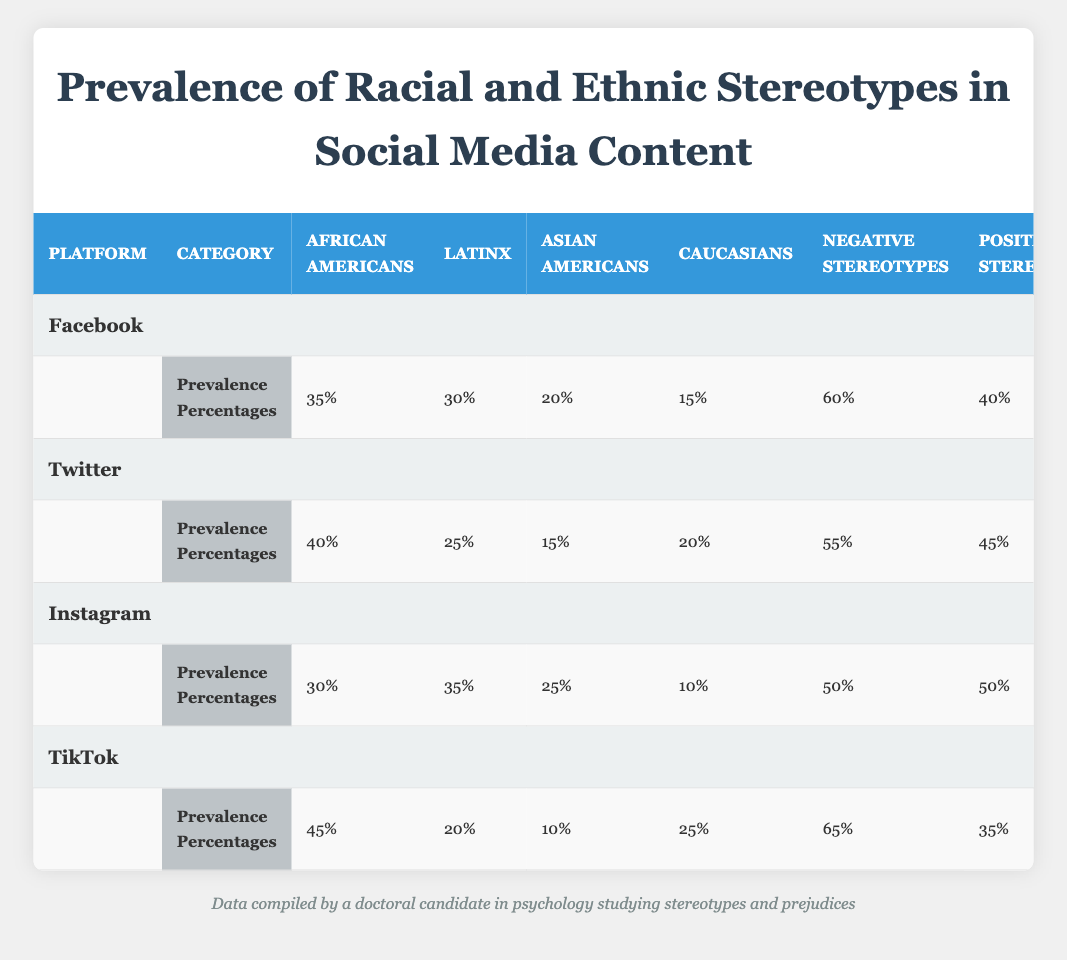What is the percentage of stereotypes about African Americans on Facebook? According to the table, the prevalence percentage of stereotypes about African Americans on Facebook is listed under the "Prevalence Percentages" section, which shows a value of 35%.
Answer: 35% Which platform has the highest percentage of negative stereotypes about Latinx individuals? The table shows that TikTok has the highest percentage of negative stereotypes about Latinx individuals at 65%, as it is the only platform for which this value is provided.
Answer: TikTok What is the difference in prevalence percentages of stereotypes about Asian Americans between Twitter and Instagram? The prevalence percentage for Asian Americans on Twitter is 15%, and on Instagram, it is 25%. The difference is calculated as 25 - 15 = 10.
Answer: 10 Is the percentage of positive stereotypes about Caucasians higher on Facebook than on Twitter? On Facebook, positive stereotypes about Caucasians are 40%, while on Twitter, they are 45%. Therefore, the percentage on Facebook is not higher than on Twitter.
Answer: No What is the average prevalence percentage of stereotypes for African Americans across all platforms? The table lists the prevalence percentages of stereotypes for African Americans on Facebook (35), Twitter (40), Instagram (30), and TikTok (45). The average is calculated as (35 + 40 + 30 + 45) / 4 = 37.5.
Answer: 37.5 Which social media platform has the lowest percentage of positive stereotypes overall? The table shows that TikTok has the lowest percentage of positive stereotypes at 35%, when comparing the positive stereotypes across all listed platforms.
Answer: TikTok What percentage of stereotypes for Latinx individuals is considered negative on Instagram? In the table, the type of stereotypes for Latinx individuals on Instagram show that the negative stereotypes comprise 50% of the total, indicating a significant representation of negative stereotypes in that context.
Answer: 50% Is the prevalence percentage of stereotypes about Caucasians higher than that of Asian Americans on any platform? The table indicates that Caucasians have a higher percentage than Asian Americans on Facebook (15% vs. 20%), Twitter (20% vs. 15%), and TikTok (25% vs. 10%). Therefore, the answer is yes.
Answer: Yes 